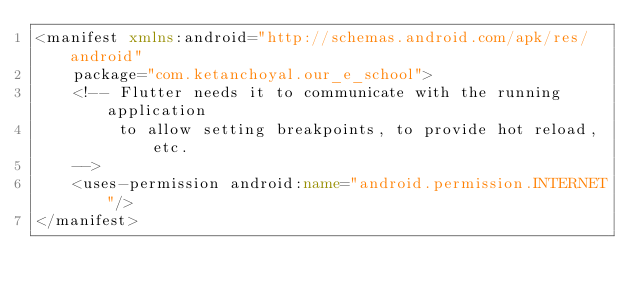<code> <loc_0><loc_0><loc_500><loc_500><_XML_><manifest xmlns:android="http://schemas.android.com/apk/res/android"
    package="com.ketanchoyal.our_e_school">
    <!-- Flutter needs it to communicate with the running application
         to allow setting breakpoints, to provide hot reload, etc.
    -->
    <uses-permission android:name="android.permission.INTERNET"/>
</manifest>
</code> 